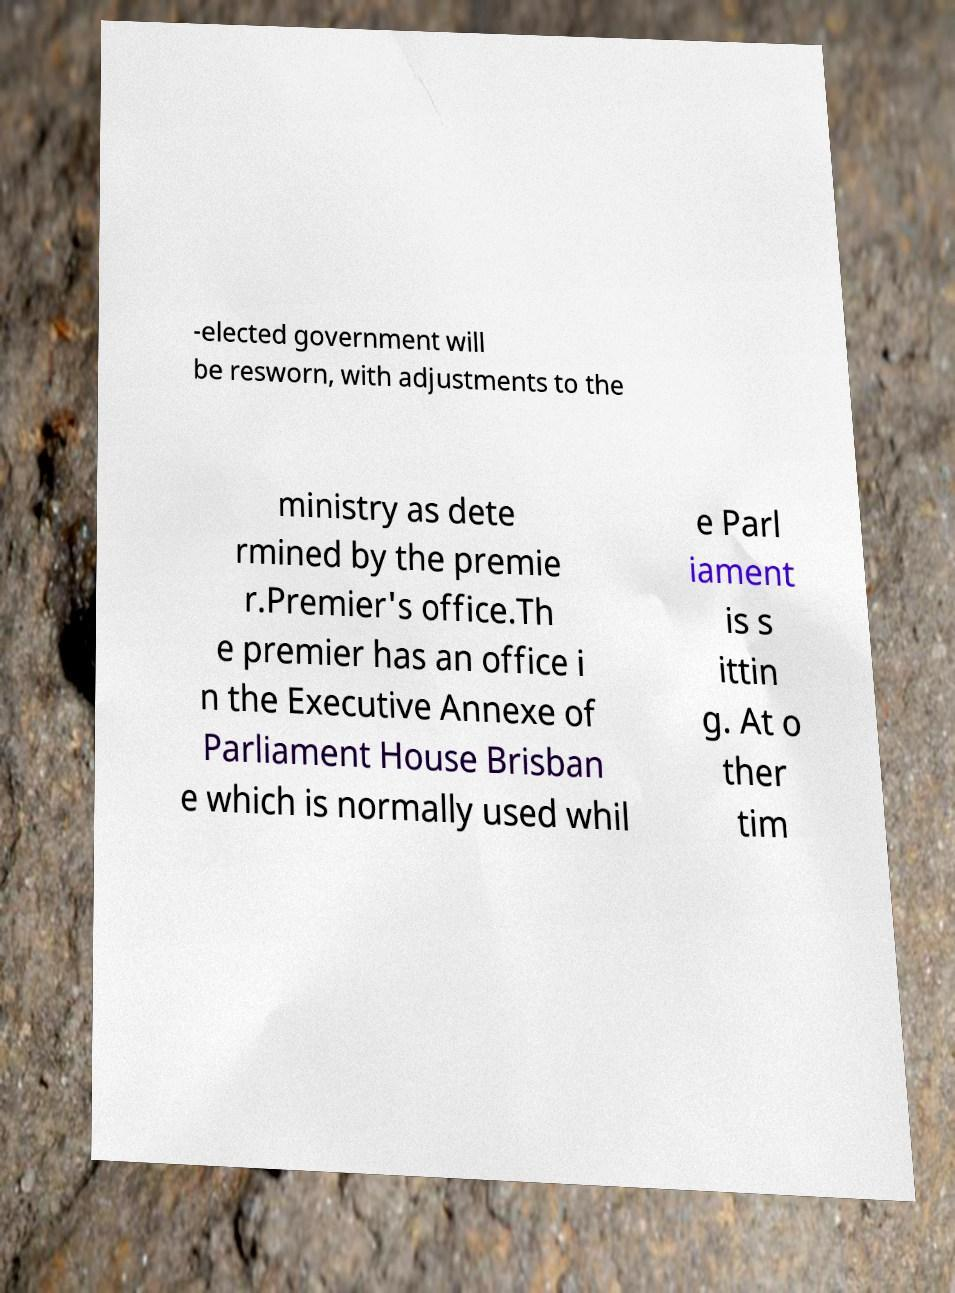Could you extract and type out the text from this image? -elected government will be resworn, with adjustments to the ministry as dete rmined by the premie r.Premier's office.Th e premier has an office i n the Executive Annexe of Parliament House Brisban e which is normally used whil e Parl iament is s ittin g. At o ther tim 